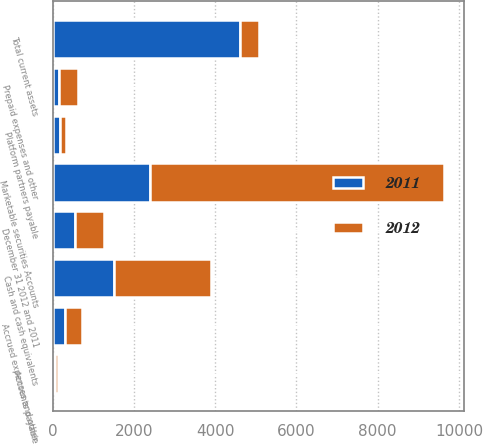Convert chart to OTSL. <chart><loc_0><loc_0><loc_500><loc_500><stacked_bar_chart><ecel><fcel>Cash and cash equivalents<fcel>Marketable securities Accounts<fcel>December 31 2012 and 2011<fcel>Prepaid expenses and other<fcel>Total current assets<fcel>Accounts payable<fcel>Platform partners payable<fcel>Accrued expenses and other<nl><fcel>2012<fcel>2384<fcel>7242<fcel>719<fcel>471<fcel>471<fcel>65<fcel>169<fcel>423<nl><fcel>2011<fcel>1512<fcel>2396<fcel>547<fcel>149<fcel>4604<fcel>63<fcel>171<fcel>296<nl></chart> 